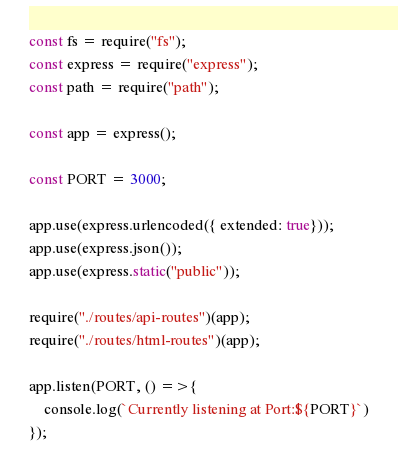<code> <loc_0><loc_0><loc_500><loc_500><_JavaScript_>const fs = require("fs");
const express = require("express");
const path = require("path");

const app = express();

const PORT = 3000;

app.use(express.urlencoded({ extended: true}));
app.use(express.json());
app.use(express.static("public"));

require("./routes/api-routes")(app);
require("./routes/html-routes")(app);

app.listen(PORT, () =>{
    console.log(`Currently listening at Port:${PORT}`)
});

</code> 